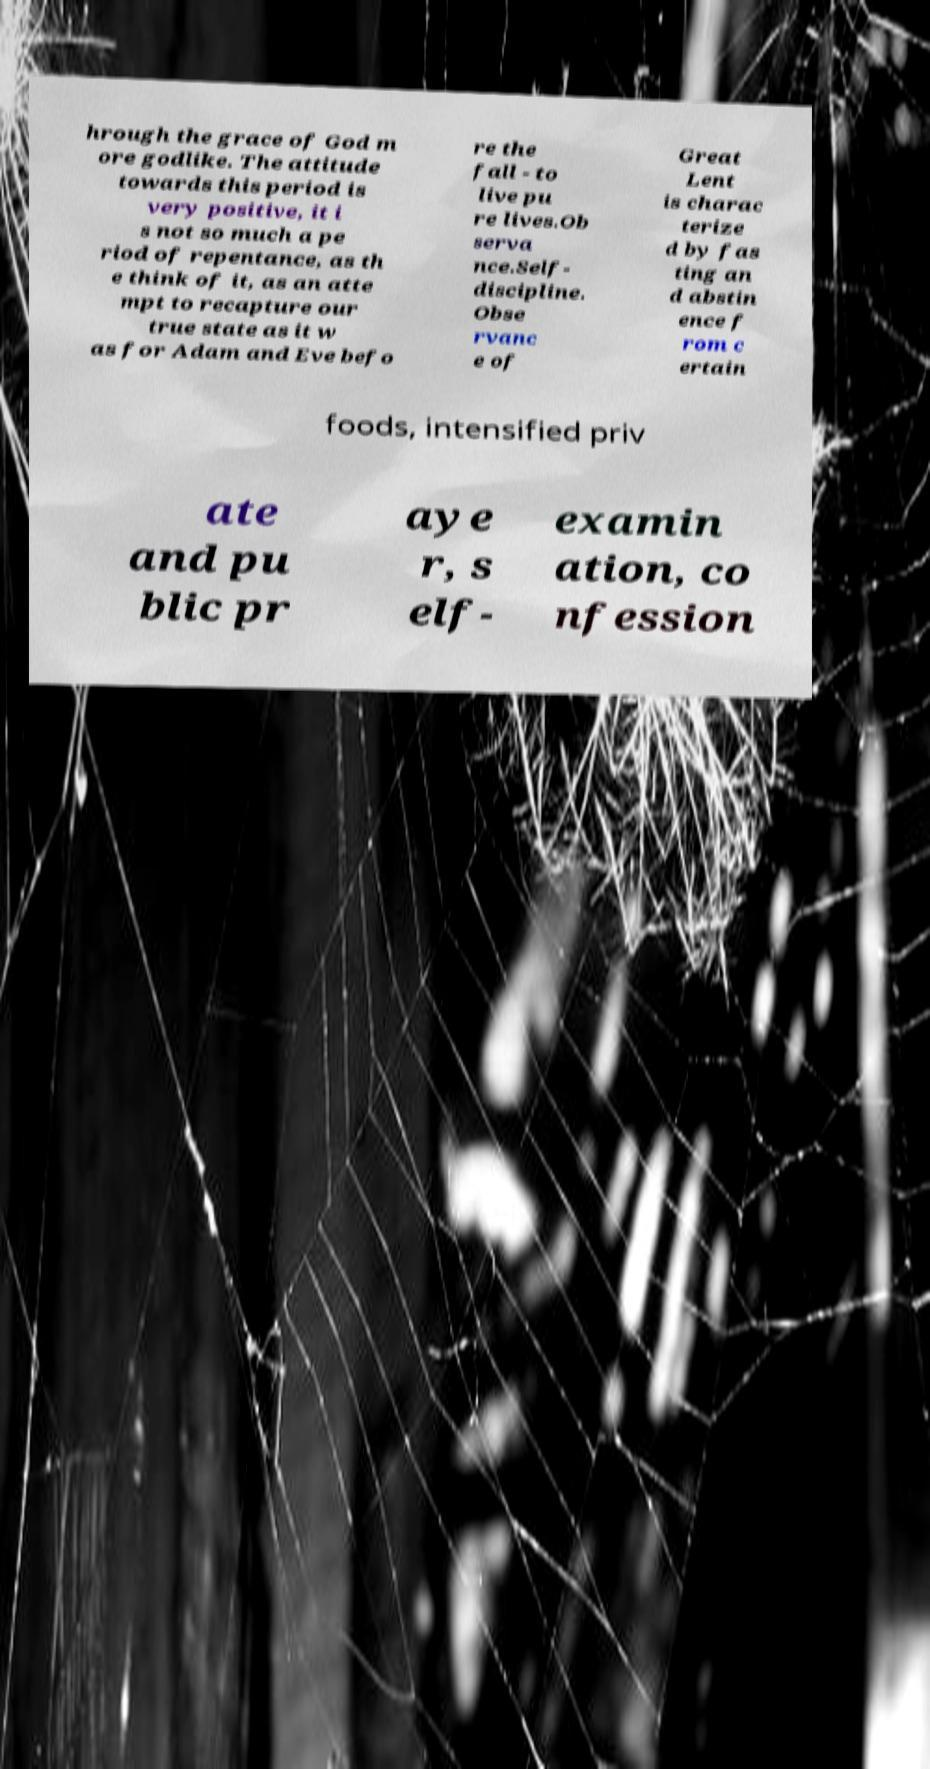Could you assist in decoding the text presented in this image and type it out clearly? hrough the grace of God m ore godlike. The attitude towards this period is very positive, it i s not so much a pe riod of repentance, as th e think of it, as an atte mpt to recapture our true state as it w as for Adam and Eve befo re the fall - to live pu re lives.Ob serva nce.Self- discipline. Obse rvanc e of Great Lent is charac terize d by fas ting an d abstin ence f rom c ertain foods, intensified priv ate and pu blic pr aye r, s elf- examin ation, co nfession 